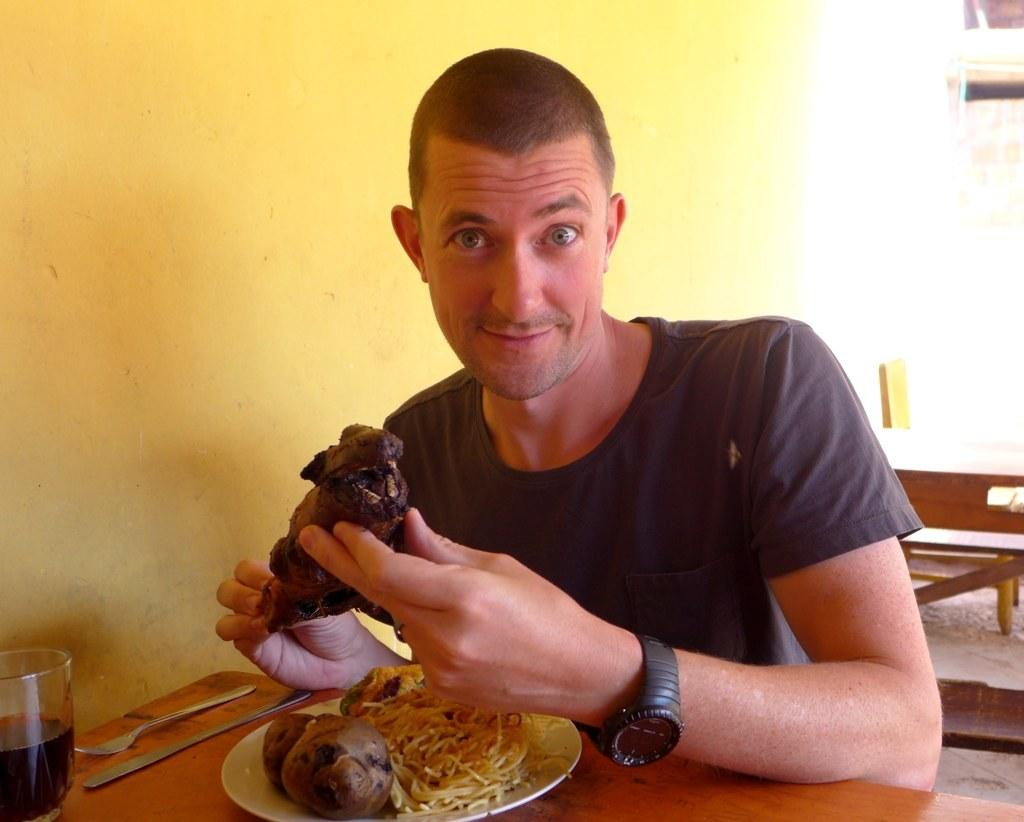What can be seen in the background of the image? There is a wall in the image. What is the person wearing in the image? The person is wearing a black shirt in the image. What piece of furniture is present in the image? There is a table in the image. What items are on the table in the image? There is a glass and a plate on the table in the image. What is on the plate in the image? There is a dish in the plate in the image. Can you tell me how many berries are on the plate in the image? There is no mention of berries in the image; the plate contains a dish. Is there a horse present in the image? There is no horse present in the image. 